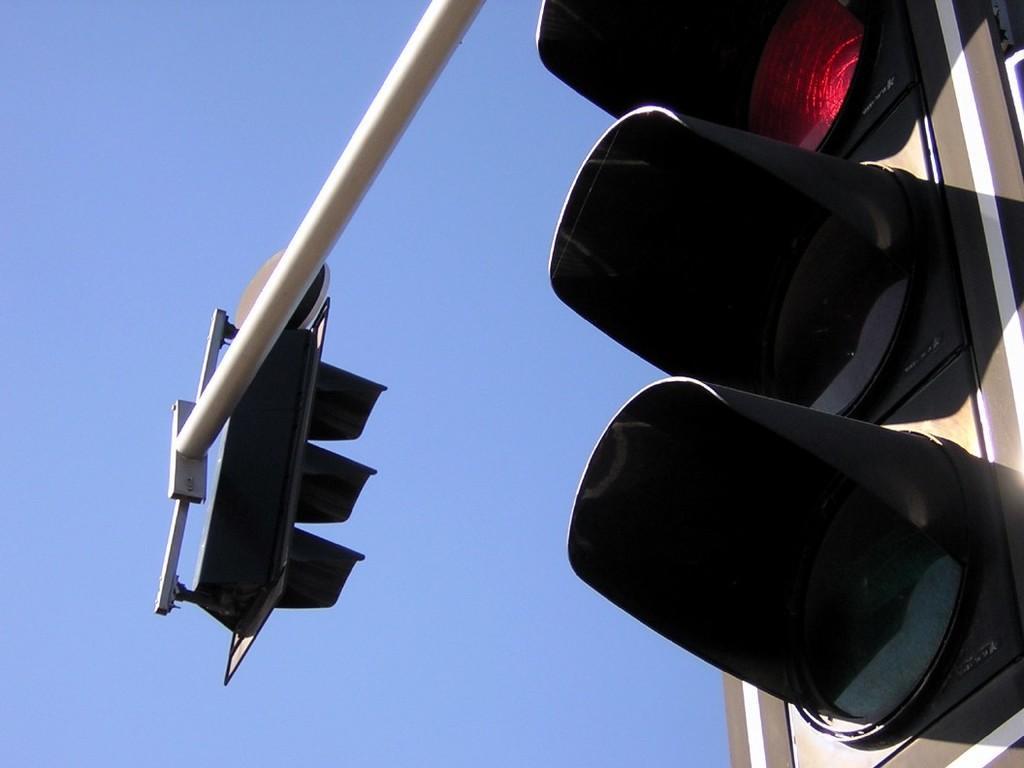Could you give a brief overview of what you see in this image? In this we can see a traffic signals, pole and a clear sky. 